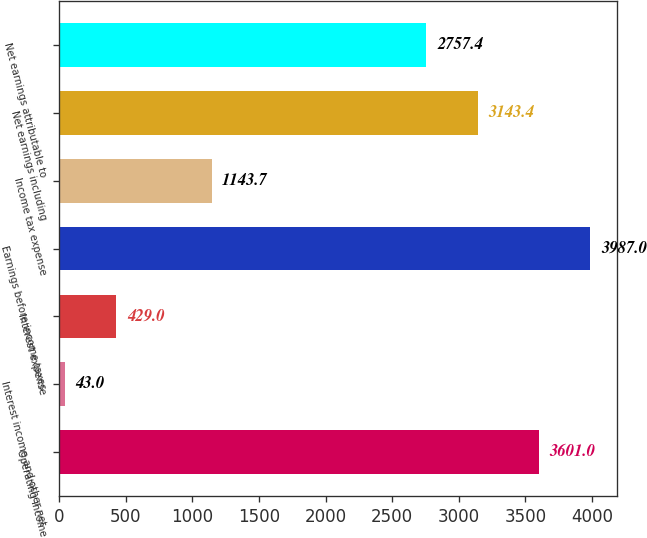Convert chart. <chart><loc_0><loc_0><loc_500><loc_500><bar_chart><fcel>Operating income<fcel>Interest income and other net<fcel>Interest expense<fcel>Earnings before income taxes<fcel>Income tax expense<fcel>Net earnings including<fcel>Net earnings attributable to<nl><fcel>3601<fcel>43<fcel>429<fcel>3987<fcel>1143.7<fcel>3143.4<fcel>2757.4<nl></chart> 